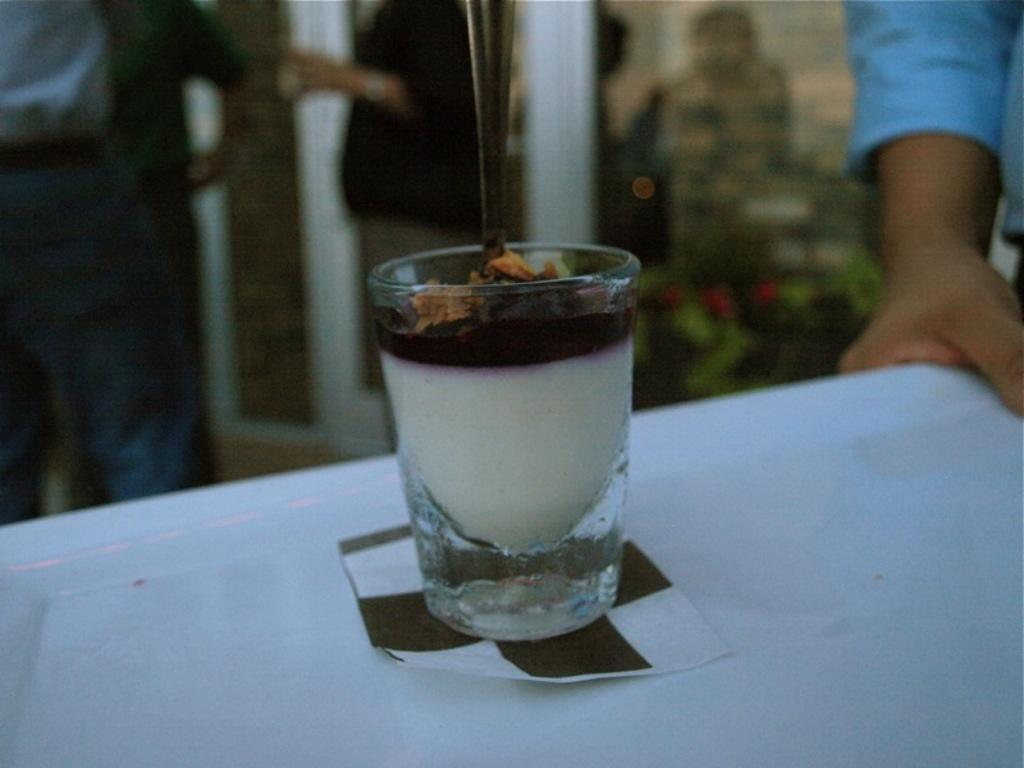Describe this image in one or two sentences. At the bottom of the image there is a tray with glass. Inside the glass there is an item with a spoon in it. Under the glass there is a tissue. In the top right corner of the image there is a person hand holding the tray. In the background there are few people standing and also there is a glass door. 